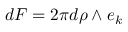Convert formula to latex. <formula><loc_0><loc_0><loc_500><loc_500>d F = 2 \pi d \rho \wedge e _ { k }</formula> 